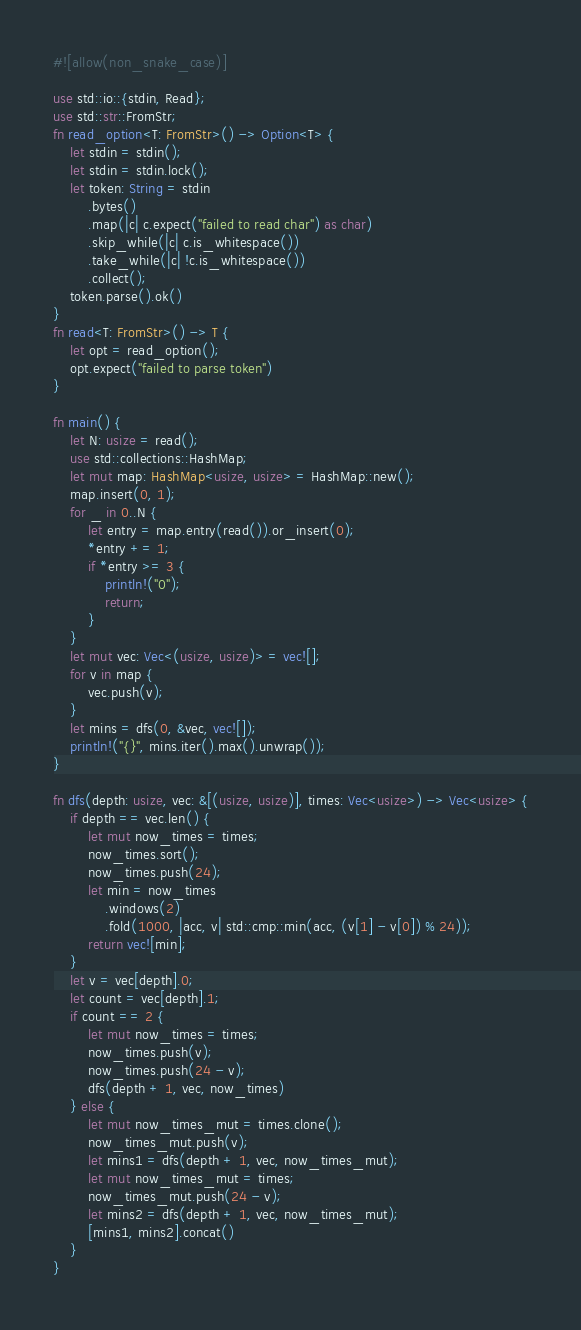Convert code to text. <code><loc_0><loc_0><loc_500><loc_500><_Rust_>#![allow(non_snake_case)]

use std::io::{stdin, Read};
use std::str::FromStr;
fn read_option<T: FromStr>() -> Option<T> {
    let stdin = stdin();
    let stdin = stdin.lock();
    let token: String = stdin
        .bytes()
        .map(|c| c.expect("failed to read char") as char)
        .skip_while(|c| c.is_whitespace())
        .take_while(|c| !c.is_whitespace())
        .collect();
    token.parse().ok()
}
fn read<T: FromStr>() -> T {
    let opt = read_option();
    opt.expect("failed to parse token")
}

fn main() {
    let N: usize = read();
    use std::collections::HashMap;
    let mut map: HashMap<usize, usize> = HashMap::new();
    map.insert(0, 1);
    for _ in 0..N {
        let entry = map.entry(read()).or_insert(0);
        *entry += 1;
        if *entry >= 3 {
            println!("0");
            return;
        }
    }
    let mut vec: Vec<(usize, usize)> = vec![];
    for v in map {
        vec.push(v);
    }
    let mins = dfs(0, &vec, vec![]);
    println!("{}", mins.iter().max().unwrap());
}

fn dfs(depth: usize, vec: &[(usize, usize)], times: Vec<usize>) -> Vec<usize> {
    if depth == vec.len() {
        let mut now_times = times;
        now_times.sort();
        now_times.push(24);
        let min = now_times
            .windows(2)
            .fold(1000, |acc, v| std::cmp::min(acc, (v[1] - v[0]) % 24));
        return vec![min];
    }
    let v = vec[depth].0;
    let count = vec[depth].1;
    if count == 2 {
        let mut now_times = times;
        now_times.push(v);
        now_times.push(24 - v);
        dfs(depth + 1, vec, now_times)
    } else {
        let mut now_times_mut = times.clone();
        now_times_mut.push(v);
        let mins1 = dfs(depth + 1, vec, now_times_mut);
        let mut now_times_mut = times;
        now_times_mut.push(24 - v);
        let mins2 = dfs(depth + 1, vec, now_times_mut);
        [mins1, mins2].concat()
    }
}
</code> 